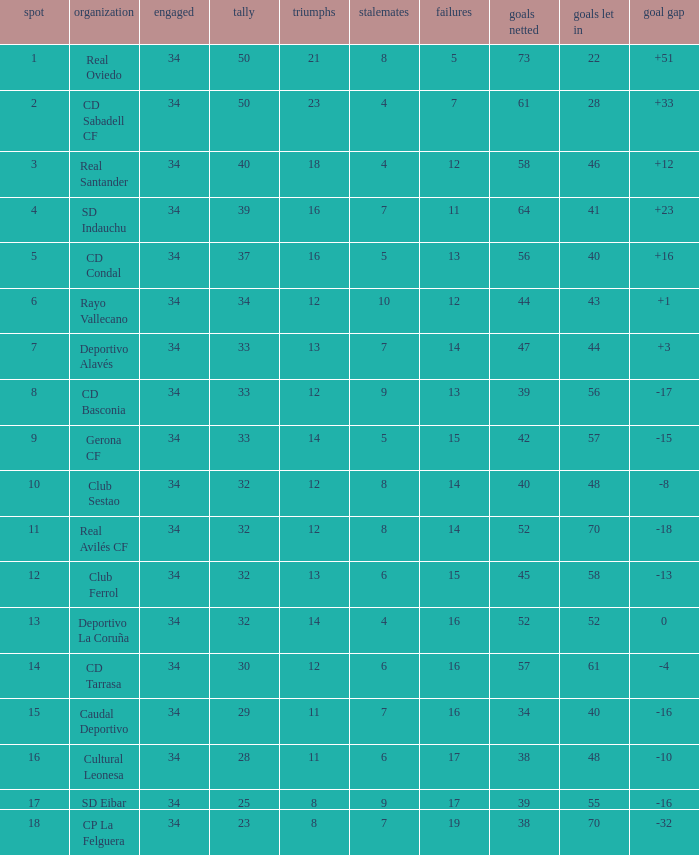Which Losses have a Goal Difference of -16, and less than 8 wins? None. 